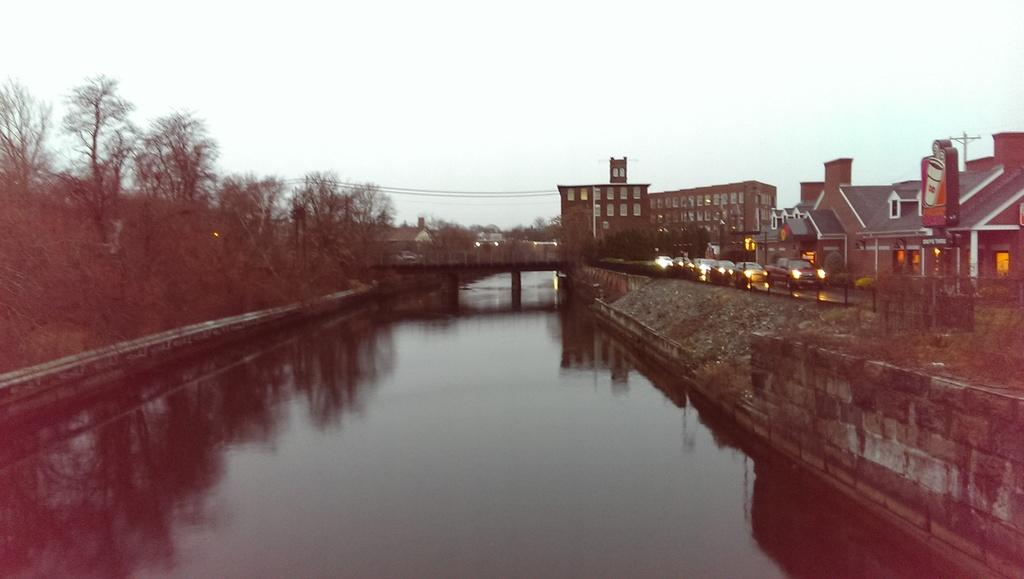What type of natural elements can be seen in the image? There are trees in the image. What type of man-made structures are present in the image? There are buildings in the image. What type of illumination is visible in the image? There are lights in the image. What type of vertical structures are present in the image? There are poles in the image. What type of transportation is visible in the image? There are vehicles on the road in the image. What type of infrastructure is present in the image? There is a bridge in the image. What type of body of water is visible in the image? There is water visible at the bottom of the image. What type of natural element is visible at the top of the image? There is sky visible at the top of the image. How many snakes are slithering on the bridge in the image? There are no snakes present in the image. What word is written on the side of the building in the image? There is no word written on the side of the building in the image. 